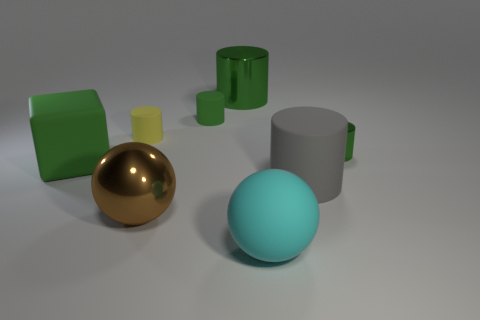There is a large metal thing that is the same color as the big block; what shape is it?
Keep it short and to the point. Cylinder. There is a tiny cylinder that is the same color as the tiny metal thing; what material is it?
Provide a succinct answer. Rubber. Do the small matte thing that is to the right of the big brown object and the metallic thing behind the small green metallic cylinder have the same color?
Offer a terse response. Yes. There is a yellow object that is made of the same material as the cyan sphere; what is its shape?
Provide a short and direct response. Cylinder. Is the number of metal cylinders that are right of the cyan matte thing greater than the number of tiny blue metallic cylinders?
Ensure brevity in your answer.  Yes. How many large blocks have the same color as the small metallic cylinder?
Offer a terse response. 1. How many other objects are there of the same color as the small metallic cylinder?
Give a very brief answer. 3. Is the number of rubber blocks greater than the number of small rubber cylinders?
Offer a very short reply. No. What is the large gray object made of?
Offer a terse response. Rubber. Do the green matte thing to the right of the yellow cylinder and the big rubber ball have the same size?
Make the answer very short. No. 